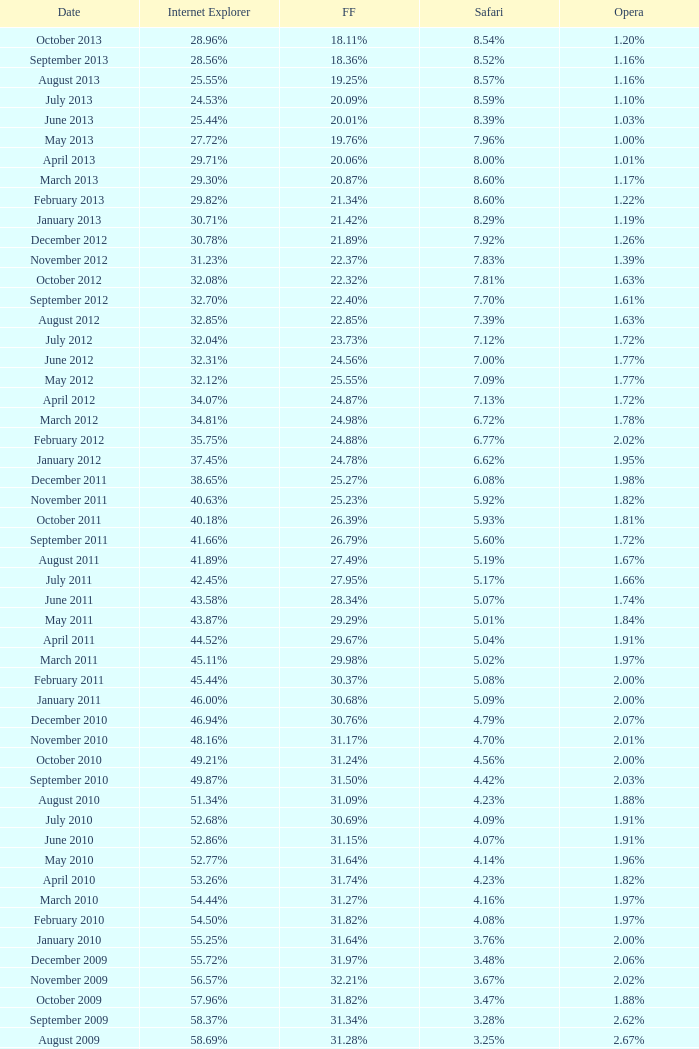What percentage of browsers were using Opera in November 2009? 2.02%. 